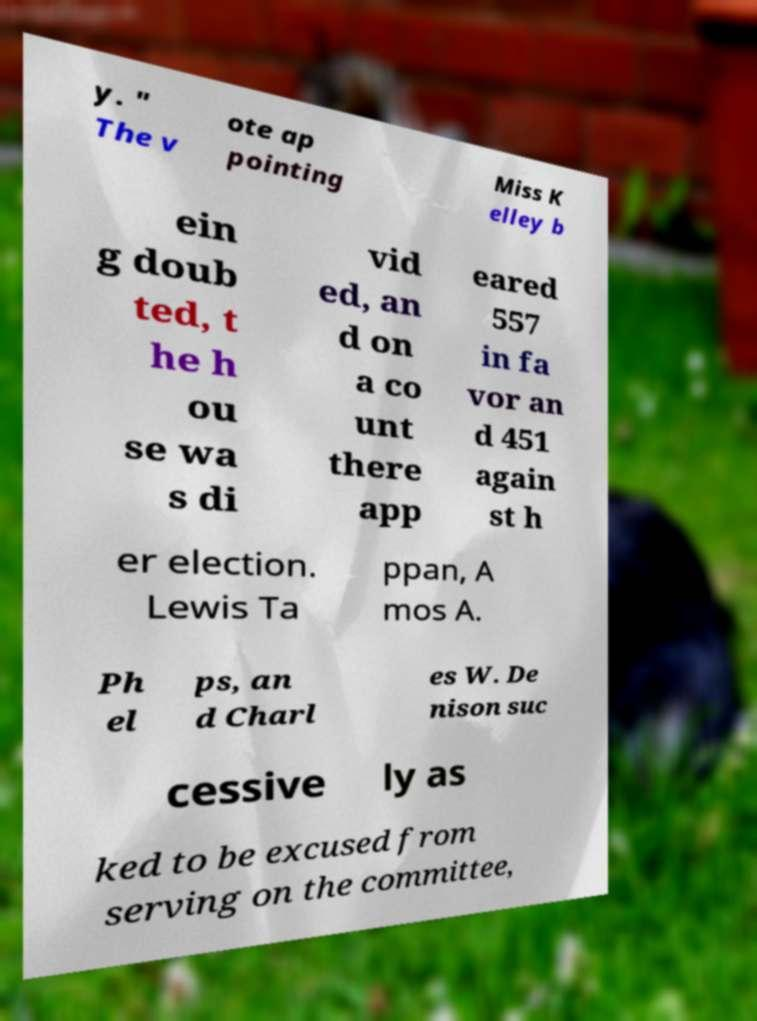Please read and relay the text visible in this image. What does it say? y. " The v ote ap pointing Miss K elley b ein g doub ted, t he h ou se wa s di vid ed, an d on a co unt there app eared 557 in fa vor an d 451 again st h er election. Lewis Ta ppan, A mos A. Ph el ps, an d Charl es W. De nison suc cessive ly as ked to be excused from serving on the committee, 